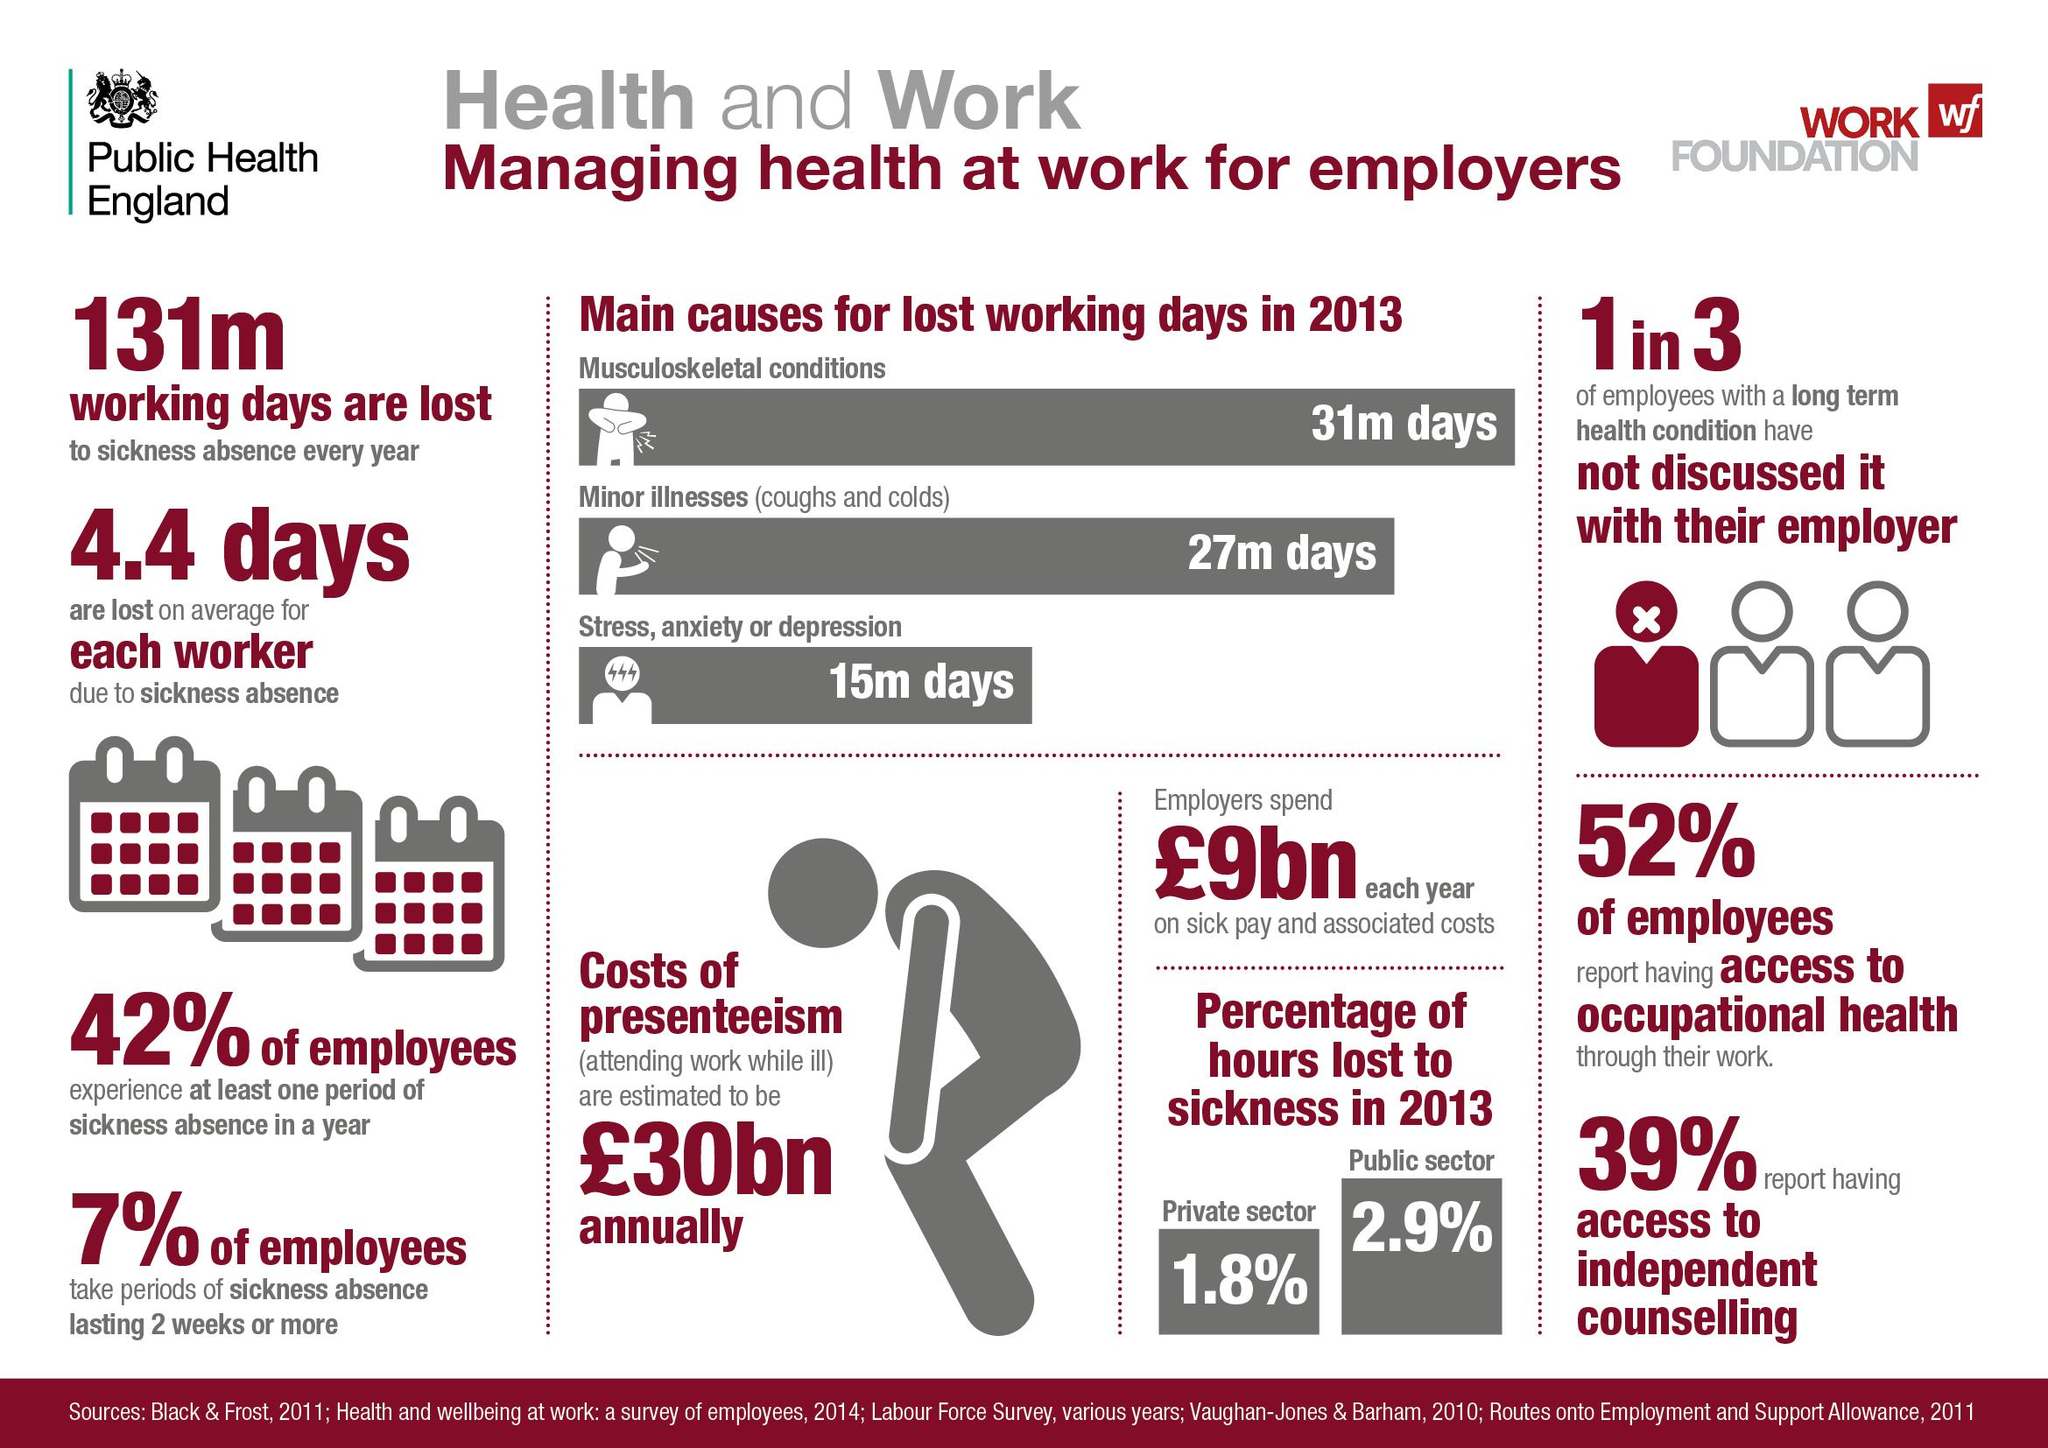Identify some key points in this picture. According to a recent survey, 52% of employees have access to occupational health services. The annual cost of presenteeism is estimated to be £30 billion. In 2013, a total of 31 million working days were lost due to musculoskeletal conditions. According to our data, 7% of employees take periods of sickness absence lasting 2 weeks or more. Presenteeism refers to the act of attending work while being ill, which can negatively impact an individual's health, productivity, and overall well-being. 